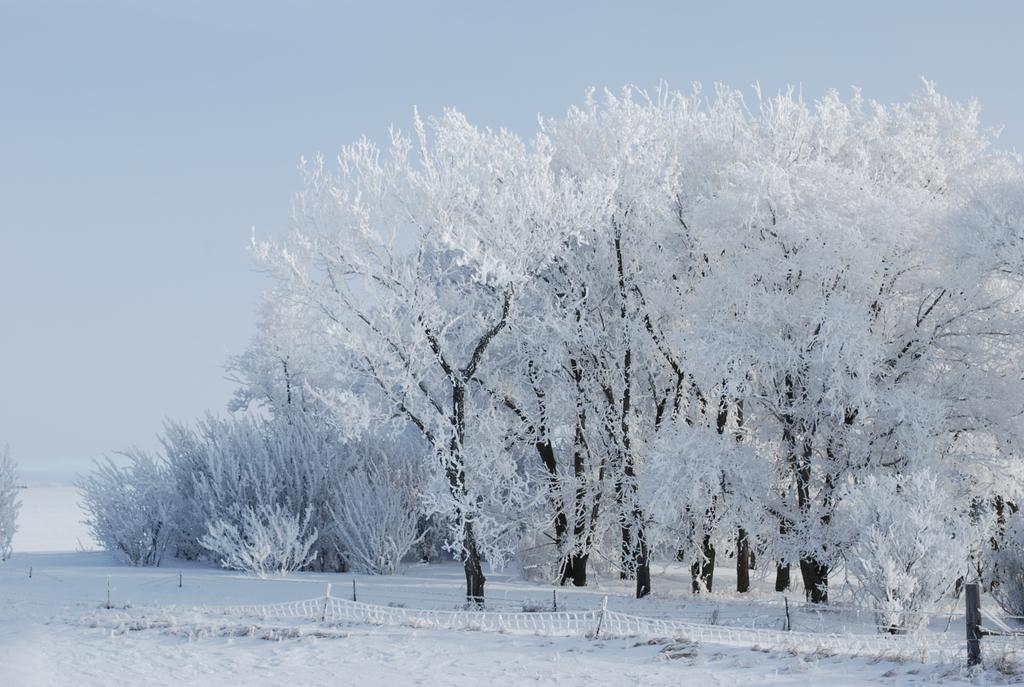What type of weather is depicted in the image? A: There is snow on the ground in the image, indicating a winter scene. What structures can be seen on the ground in the image? There are poles with fences on the ground in the image. What type of vegetation is present in the image? There are trees and bushes on the ground in the image. What is visible at the top of the image? The sky is visible at the top of the image. What type of wren can be seen flying in the image? There is no wren present in the image; it features snow, poles with fences, trees, bushes, and a visible sky. What decision does the coach make in the image? There is no coach or decision-making process depicted in the image. 